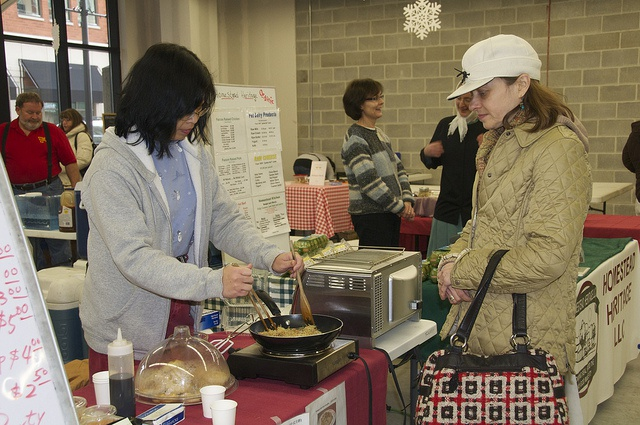Describe the objects in this image and their specific colors. I can see people in brown, darkgray, black, and gray tones, people in brown, tan, olive, and gray tones, handbag in gray, black, tan, and brown tones, microwave in brown, gray, and black tones, and people in brown, black, and gray tones in this image. 